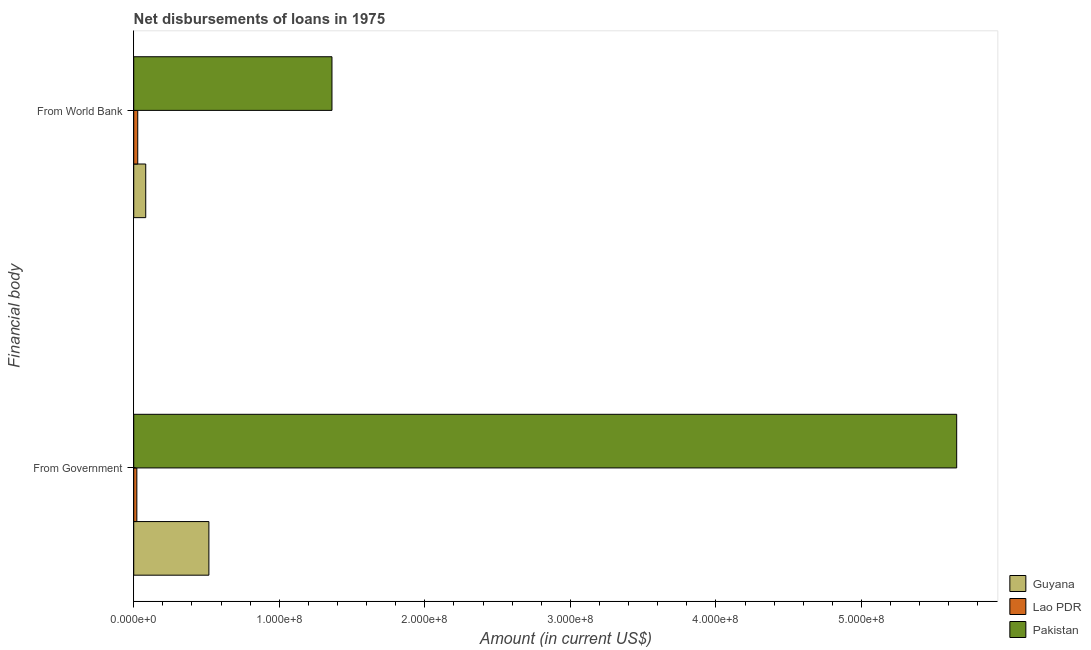How many groups of bars are there?
Keep it short and to the point. 2. Are the number of bars per tick equal to the number of legend labels?
Your answer should be very brief. Yes. How many bars are there on the 2nd tick from the top?
Your answer should be compact. 3. What is the label of the 2nd group of bars from the top?
Ensure brevity in your answer.  From Government. What is the net disbursements of loan from government in Pakistan?
Your answer should be compact. 5.65e+08. Across all countries, what is the maximum net disbursements of loan from world bank?
Your answer should be very brief. 1.36e+08. Across all countries, what is the minimum net disbursements of loan from world bank?
Offer a very short reply. 2.76e+06. In which country was the net disbursements of loan from government minimum?
Give a very brief answer. Lao PDR. What is the total net disbursements of loan from government in the graph?
Offer a very short reply. 6.19e+08. What is the difference between the net disbursements of loan from world bank in Pakistan and that in Guyana?
Provide a succinct answer. 1.28e+08. What is the difference between the net disbursements of loan from world bank in Pakistan and the net disbursements of loan from government in Lao PDR?
Provide a succinct answer. 1.34e+08. What is the average net disbursements of loan from government per country?
Provide a succinct answer. 2.06e+08. What is the difference between the net disbursements of loan from world bank and net disbursements of loan from government in Lao PDR?
Make the answer very short. 6.28e+05. What is the ratio of the net disbursements of loan from world bank in Lao PDR to that in Pakistan?
Offer a very short reply. 0.02. In how many countries, is the net disbursements of loan from world bank greater than the average net disbursements of loan from world bank taken over all countries?
Provide a succinct answer. 1. What does the 1st bar from the bottom in From Government represents?
Ensure brevity in your answer.  Guyana. How many bars are there?
Provide a short and direct response. 6. How many countries are there in the graph?
Ensure brevity in your answer.  3. Where does the legend appear in the graph?
Provide a short and direct response. Bottom right. How many legend labels are there?
Your answer should be very brief. 3. How are the legend labels stacked?
Ensure brevity in your answer.  Vertical. What is the title of the graph?
Your response must be concise. Net disbursements of loans in 1975. Does "United States" appear as one of the legend labels in the graph?
Offer a very short reply. No. What is the label or title of the Y-axis?
Your response must be concise. Financial body. What is the Amount (in current US$) of Guyana in From Government?
Your response must be concise. 5.16e+07. What is the Amount (in current US$) in Lao PDR in From Government?
Offer a very short reply. 2.13e+06. What is the Amount (in current US$) in Pakistan in From Government?
Your answer should be compact. 5.65e+08. What is the Amount (in current US$) of Guyana in From World Bank?
Offer a terse response. 8.24e+06. What is the Amount (in current US$) in Lao PDR in From World Bank?
Make the answer very short. 2.76e+06. What is the Amount (in current US$) of Pakistan in From World Bank?
Your response must be concise. 1.36e+08. Across all Financial body, what is the maximum Amount (in current US$) of Guyana?
Make the answer very short. 5.16e+07. Across all Financial body, what is the maximum Amount (in current US$) of Lao PDR?
Your response must be concise. 2.76e+06. Across all Financial body, what is the maximum Amount (in current US$) of Pakistan?
Your answer should be compact. 5.65e+08. Across all Financial body, what is the minimum Amount (in current US$) of Guyana?
Keep it short and to the point. 8.24e+06. Across all Financial body, what is the minimum Amount (in current US$) in Lao PDR?
Give a very brief answer. 2.13e+06. Across all Financial body, what is the minimum Amount (in current US$) of Pakistan?
Provide a succinct answer. 1.36e+08. What is the total Amount (in current US$) in Guyana in the graph?
Give a very brief answer. 5.99e+07. What is the total Amount (in current US$) in Lao PDR in the graph?
Keep it short and to the point. 4.89e+06. What is the total Amount (in current US$) of Pakistan in the graph?
Offer a terse response. 7.02e+08. What is the difference between the Amount (in current US$) in Guyana in From Government and that in From World Bank?
Keep it short and to the point. 4.34e+07. What is the difference between the Amount (in current US$) in Lao PDR in From Government and that in From World Bank?
Ensure brevity in your answer.  -6.28e+05. What is the difference between the Amount (in current US$) of Pakistan in From Government and that in From World Bank?
Provide a succinct answer. 4.29e+08. What is the difference between the Amount (in current US$) in Guyana in From Government and the Amount (in current US$) in Lao PDR in From World Bank?
Provide a short and direct response. 4.89e+07. What is the difference between the Amount (in current US$) of Guyana in From Government and the Amount (in current US$) of Pakistan in From World Bank?
Provide a succinct answer. -8.46e+07. What is the difference between the Amount (in current US$) of Lao PDR in From Government and the Amount (in current US$) of Pakistan in From World Bank?
Ensure brevity in your answer.  -1.34e+08. What is the average Amount (in current US$) in Guyana per Financial body?
Give a very brief answer. 2.99e+07. What is the average Amount (in current US$) in Lao PDR per Financial body?
Your response must be concise. 2.44e+06. What is the average Amount (in current US$) of Pakistan per Financial body?
Keep it short and to the point. 3.51e+08. What is the difference between the Amount (in current US$) in Guyana and Amount (in current US$) in Lao PDR in From Government?
Your response must be concise. 4.95e+07. What is the difference between the Amount (in current US$) in Guyana and Amount (in current US$) in Pakistan in From Government?
Offer a terse response. -5.14e+08. What is the difference between the Amount (in current US$) in Lao PDR and Amount (in current US$) in Pakistan in From Government?
Keep it short and to the point. -5.63e+08. What is the difference between the Amount (in current US$) in Guyana and Amount (in current US$) in Lao PDR in From World Bank?
Your answer should be compact. 5.48e+06. What is the difference between the Amount (in current US$) in Guyana and Amount (in current US$) in Pakistan in From World Bank?
Give a very brief answer. -1.28e+08. What is the difference between the Amount (in current US$) of Lao PDR and Amount (in current US$) of Pakistan in From World Bank?
Make the answer very short. -1.33e+08. What is the ratio of the Amount (in current US$) in Guyana in From Government to that in From World Bank?
Give a very brief answer. 6.27. What is the ratio of the Amount (in current US$) of Lao PDR in From Government to that in From World Bank?
Keep it short and to the point. 0.77. What is the ratio of the Amount (in current US$) in Pakistan in From Government to that in From World Bank?
Your answer should be compact. 4.15. What is the difference between the highest and the second highest Amount (in current US$) of Guyana?
Provide a short and direct response. 4.34e+07. What is the difference between the highest and the second highest Amount (in current US$) in Lao PDR?
Provide a short and direct response. 6.28e+05. What is the difference between the highest and the second highest Amount (in current US$) in Pakistan?
Offer a very short reply. 4.29e+08. What is the difference between the highest and the lowest Amount (in current US$) in Guyana?
Offer a terse response. 4.34e+07. What is the difference between the highest and the lowest Amount (in current US$) of Lao PDR?
Make the answer very short. 6.28e+05. What is the difference between the highest and the lowest Amount (in current US$) in Pakistan?
Ensure brevity in your answer.  4.29e+08. 